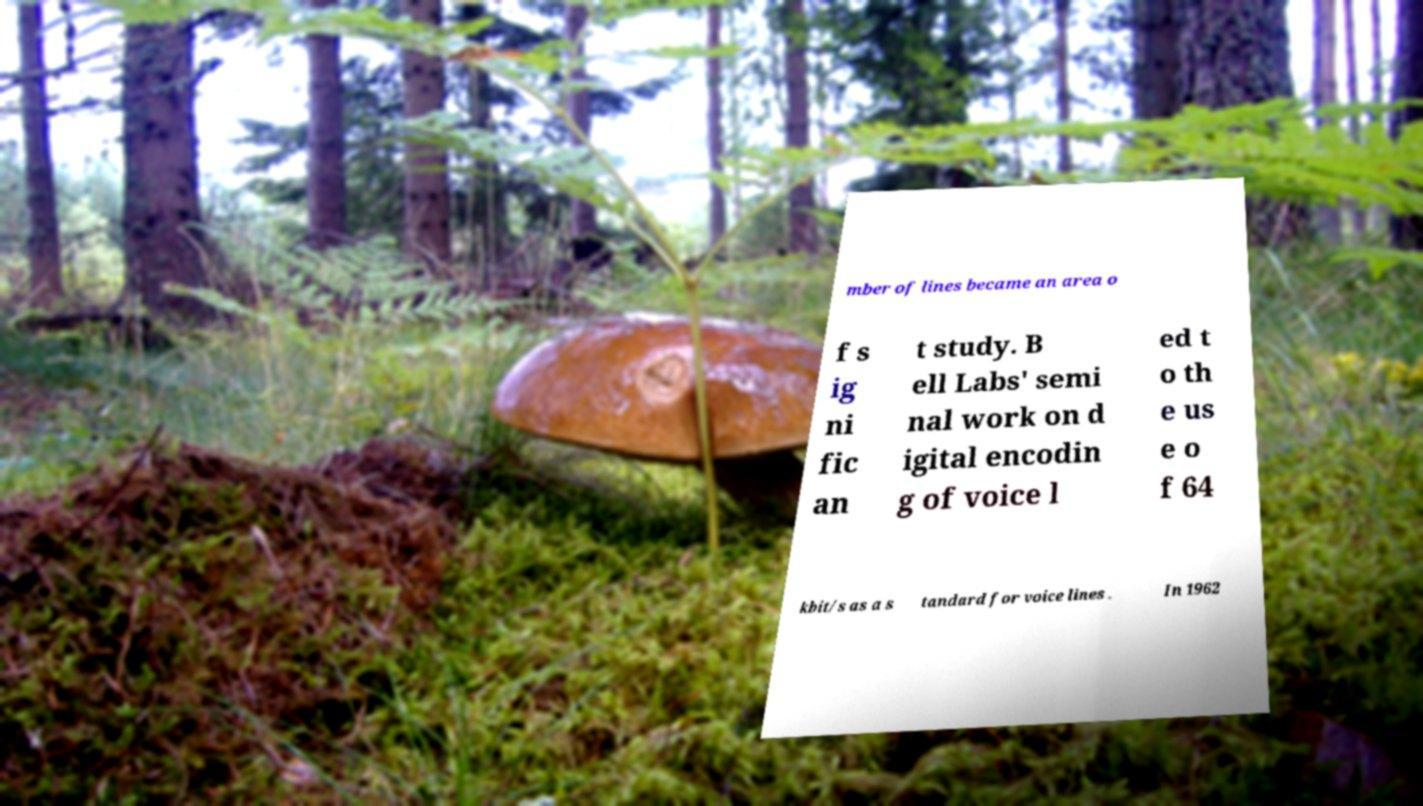Could you extract and type out the text from this image? mber of lines became an area o f s ig ni fic an t study. B ell Labs' semi nal work on d igital encodin g of voice l ed t o th e us e o f 64 kbit/s as a s tandard for voice lines . In 1962 